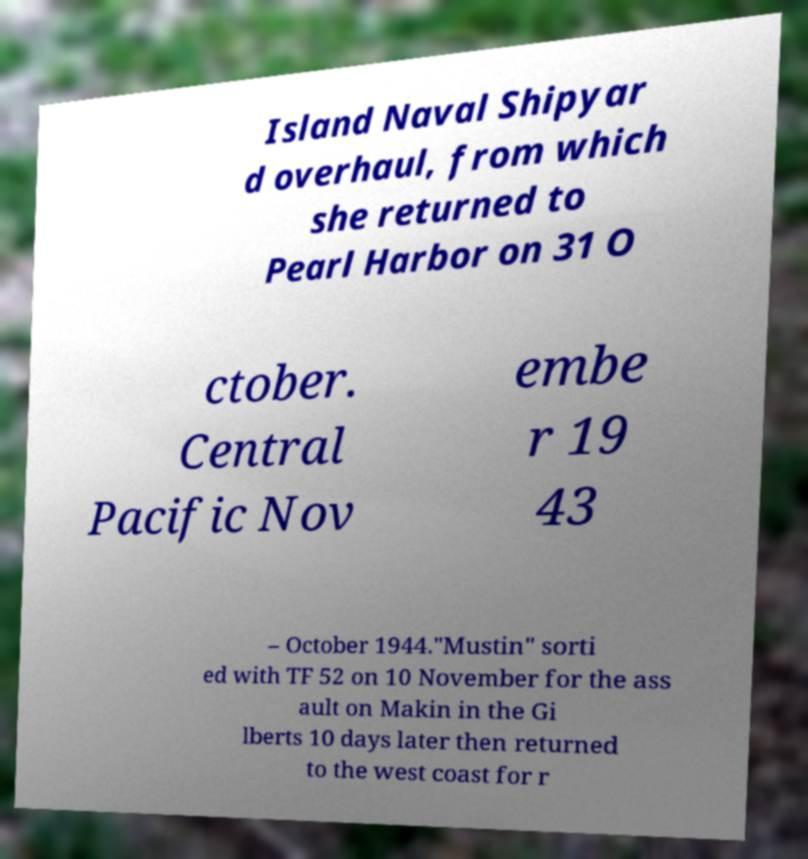Could you extract and type out the text from this image? Island Naval Shipyar d overhaul, from which she returned to Pearl Harbor on 31 O ctober. Central Pacific Nov embe r 19 43 – October 1944."Mustin" sorti ed with TF 52 on 10 November for the ass ault on Makin in the Gi lberts 10 days later then returned to the west coast for r 